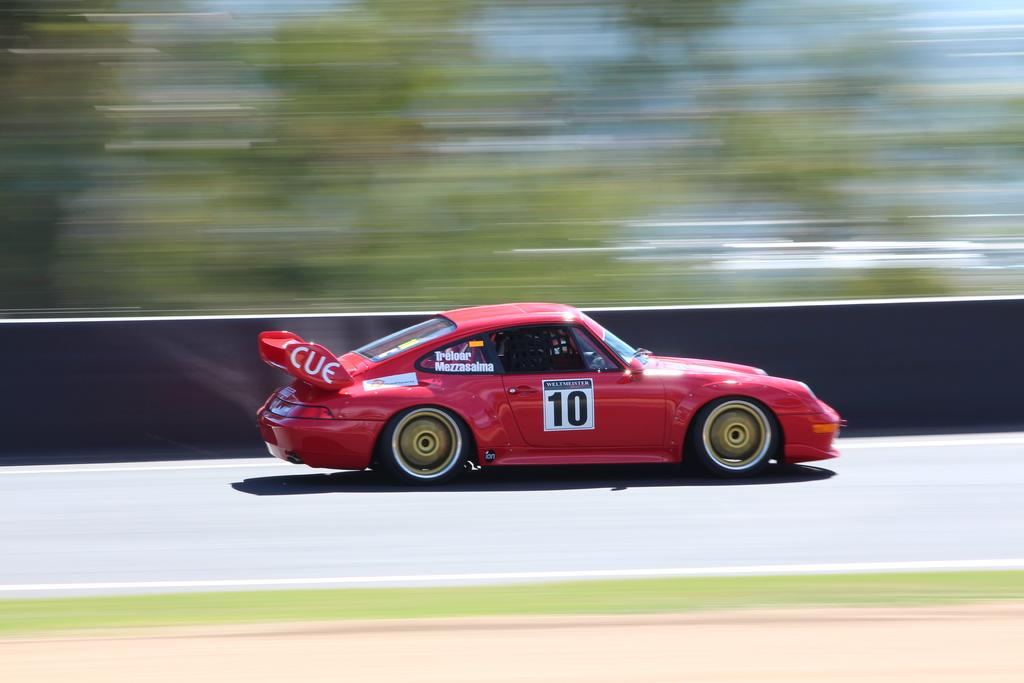What is the person in the image doing? There is a person riding a car on the road in the image. What type of surface is the car driving on? Grass is visible on the ground in the image. What can be seen in the background of the image? There is a hoarding and trees present in the background of the image. Where is the mailbox located in the image? There is no mailbox present in the image. What note is the person holding while riding the car? There is no note visible in the image; the person is simply riding a car. 